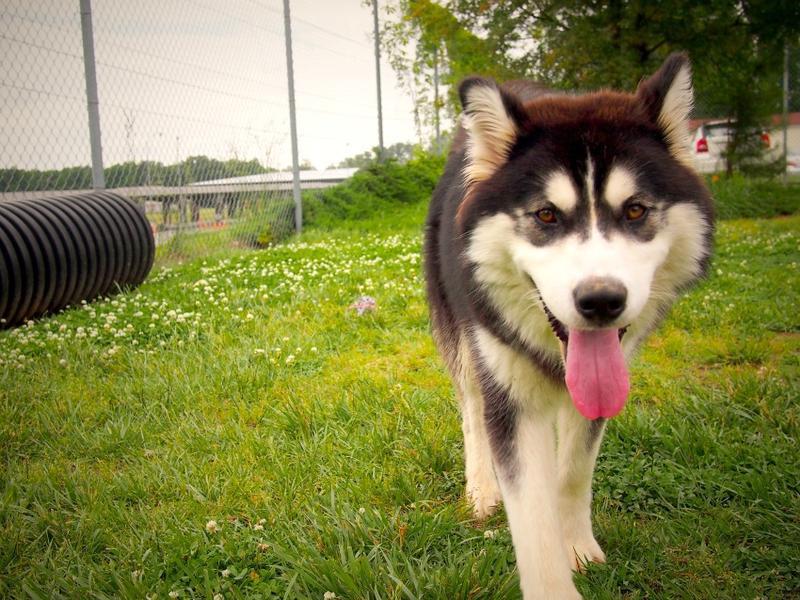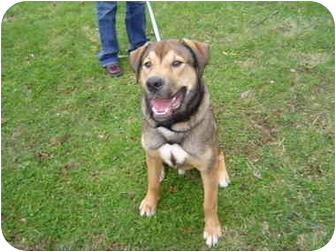The first image is the image on the left, the second image is the image on the right. Examine the images to the left and right. Is the description "The left and right image contains the same number of dogs with one sitting while the other stands with his tongue out." accurate? Answer yes or no. Yes. The first image is the image on the left, the second image is the image on the right. For the images shown, is this caption "A man is standing behind a big husky dog, who is standing with his face forward and his tongue hanging." true? Answer yes or no. No. 